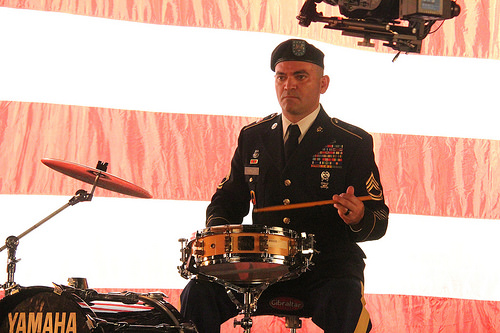<image>
Is there a drum to the left of the drummer? No. The drum is not to the left of the drummer. From this viewpoint, they have a different horizontal relationship. 